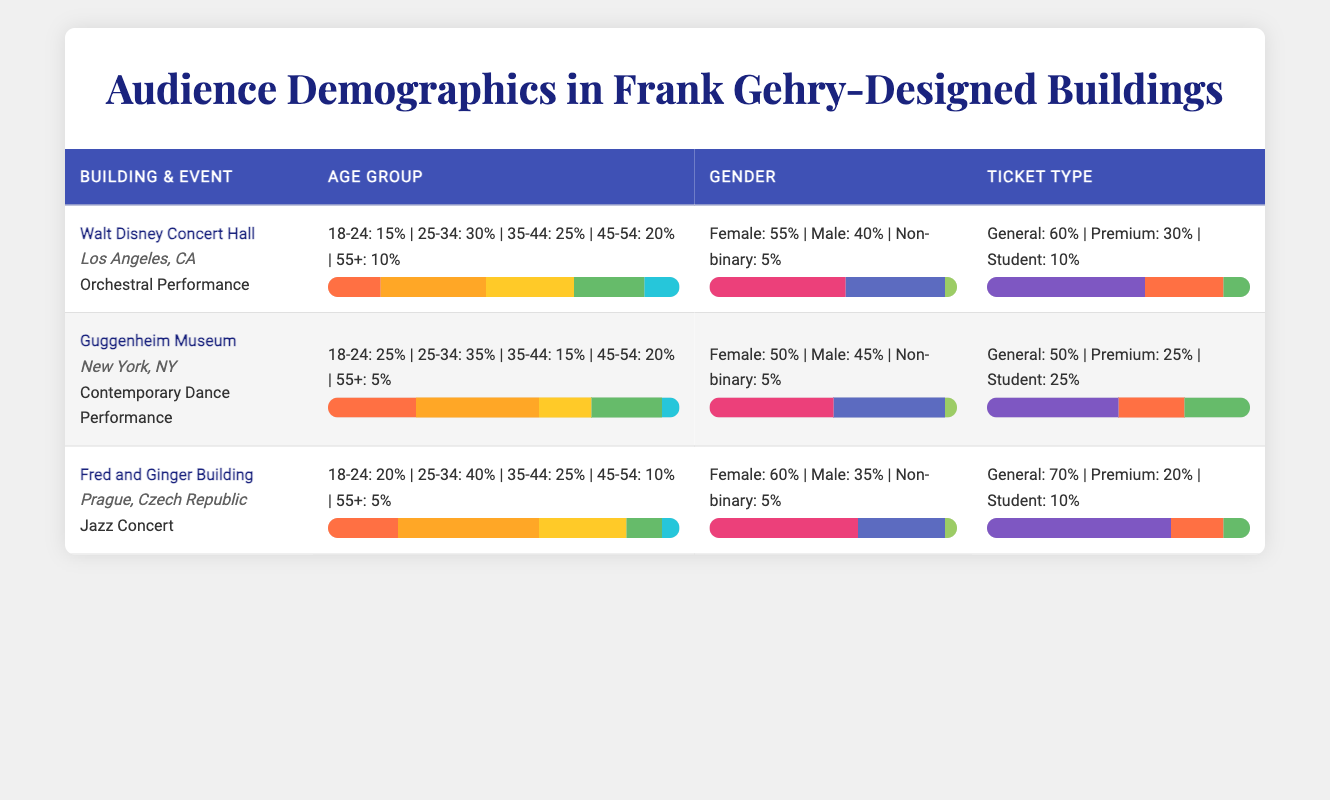What is the percentage of male audience members at the Walt Disney Concert Hall? The table shows the gender breakdown for the Walt Disney Concert Hall where male audience members account for 40%.
Answer: 40% Which ethnicity has the highest audience representation at the Guggenheim Museum? According to the table, White audience members represent 40%, which is the highest among the listed ethnicities at the Guggenheim Museum.
Answer: White How many audiences aged 25-34 attended the Fred and Ginger Building's Jazz Concert? At the Fred and Ginger Building, 40% of the audience was aged 25-34, but the exact number of audience members isn't given, so we can only refer to their percentage.
Answer: 40% True or False: The audience at the Guggenheim Museum had a higher percentage of students compared to general admission ticket holders. The ticket type breakdown shows general admission at 50% and students at 25%, indicating the statement is false.
Answer: False What is the average percentage of audience members aged 45-54 across all three performances? Adding the percentages for each venue: Walt Disney Concert Hall (20%) + Guggenheim Museum (20%) + Fred and Ginger Building (10%) = 50%. Dividing by 3 gives an average of 16.67%.
Answer: 16.67% What percentage of the audience at the Fred and Ginger Building were Czech? The ethnicity breakdown indicates that 70% of the audience at the Fred and Ginger Building identified as Czech.
Answer: 70% How does the gender breakdown at the Guggenheim Museum compare to that at the Walt Disney Concert Hall? At the Guggenheim Museum, 50% of the audience is female and 45% male, while at the Walt Disney Concert Hall, 55% is female and 40% male. This means the Guggenheim has a slightly more balanced gender ratio than the Walt Disney Concert Hall.
Answer: More balanced What is the total percentage of non-binary audience members across all three buildings? The percentages for non-binary audience members are: Walt Disney Concert Hall (5%), Guggenheim Museum (5%), and Fred and Ginger Building (5%). Summing these gives a total of 15%.
Answer: 15% Which event had the highest percentage of general admission tickets sold? At the Fred and Ginger Building for the Jazz Concert, 70% of tickets sold were general admission, the highest percentage among all events listed.
Answer: Jazz Concert at Fred and Ginger Building 